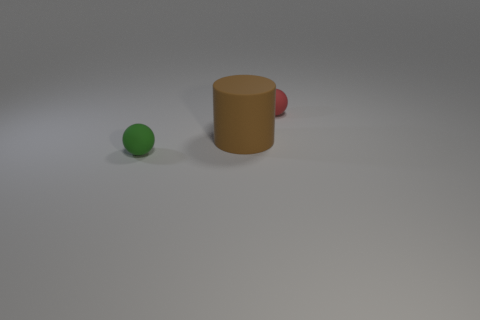There is a small thing that is left of the brown cylinder; what is its color?
Your answer should be very brief. Green. What is the size of the sphere that is made of the same material as the tiny red thing?
Offer a very short reply. Small. There is a green thing that is the same shape as the small red object; what is its size?
Offer a very short reply. Small. Are there any green objects?
Provide a short and direct response. Yes. What number of objects are balls that are behind the big object or rubber spheres?
Keep it short and to the point. 2. What is the material of the red thing that is the same size as the green object?
Offer a terse response. Rubber. There is a rubber sphere that is on the right side of the tiny ball that is in front of the brown matte cylinder; what color is it?
Offer a terse response. Red. There is a tiny red object; what number of rubber things are left of it?
Your answer should be very brief. 2. What is the color of the big cylinder?
Offer a very short reply. Brown. How many tiny things are either green matte things or rubber things?
Provide a succinct answer. 2. 